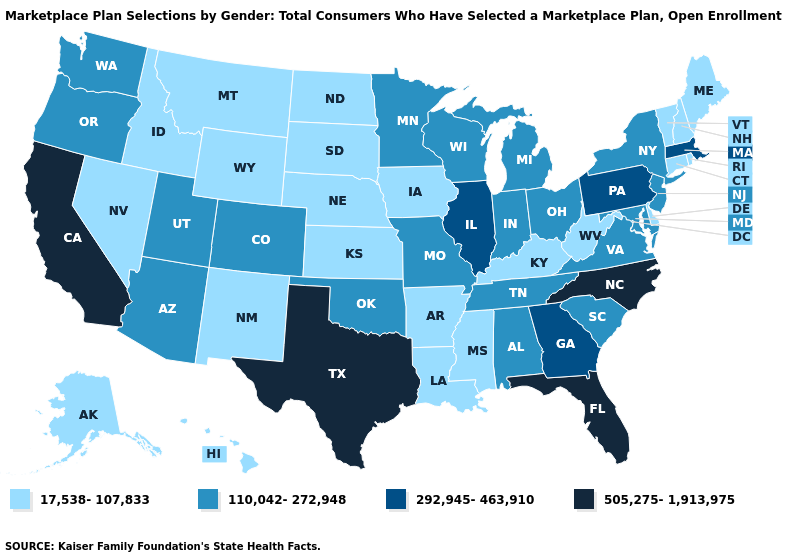Among the states that border North Carolina , does Virginia have the lowest value?
Answer briefly. Yes. What is the value of North Carolina?
Quick response, please. 505,275-1,913,975. Name the states that have a value in the range 505,275-1,913,975?
Write a very short answer. California, Florida, North Carolina, Texas. Does Washington have the same value as South Carolina?
Quick response, please. Yes. Which states have the lowest value in the USA?
Quick response, please. Alaska, Arkansas, Connecticut, Delaware, Hawaii, Idaho, Iowa, Kansas, Kentucky, Louisiana, Maine, Mississippi, Montana, Nebraska, Nevada, New Hampshire, New Mexico, North Dakota, Rhode Island, South Dakota, Vermont, West Virginia, Wyoming. What is the value of Kansas?
Short answer required. 17,538-107,833. Does the map have missing data?
Keep it brief. No. What is the value of South Carolina?
Concise answer only. 110,042-272,948. What is the value of Utah?
Short answer required. 110,042-272,948. What is the value of Nevada?
Keep it brief. 17,538-107,833. Name the states that have a value in the range 17,538-107,833?
Give a very brief answer. Alaska, Arkansas, Connecticut, Delaware, Hawaii, Idaho, Iowa, Kansas, Kentucky, Louisiana, Maine, Mississippi, Montana, Nebraska, Nevada, New Hampshire, New Mexico, North Dakota, Rhode Island, South Dakota, Vermont, West Virginia, Wyoming. What is the highest value in the MidWest ?
Concise answer only. 292,945-463,910. Name the states that have a value in the range 110,042-272,948?
Write a very short answer. Alabama, Arizona, Colorado, Indiana, Maryland, Michigan, Minnesota, Missouri, New Jersey, New York, Ohio, Oklahoma, Oregon, South Carolina, Tennessee, Utah, Virginia, Washington, Wisconsin. Which states hav the highest value in the South?
Write a very short answer. Florida, North Carolina, Texas. What is the value of Ohio?
Give a very brief answer. 110,042-272,948. 